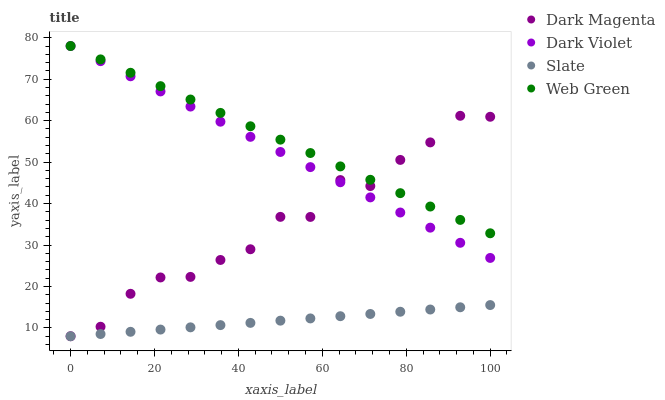Does Slate have the minimum area under the curve?
Answer yes or no. Yes. Does Web Green have the maximum area under the curve?
Answer yes or no. Yes. Does Dark Magenta have the minimum area under the curve?
Answer yes or no. No. Does Dark Magenta have the maximum area under the curve?
Answer yes or no. No. Is Slate the smoothest?
Answer yes or no. Yes. Is Dark Magenta the roughest?
Answer yes or no. Yes. Is Web Green the smoothest?
Answer yes or no. No. Is Web Green the roughest?
Answer yes or no. No. Does Slate have the lowest value?
Answer yes or no. Yes. Does Web Green have the lowest value?
Answer yes or no. No. Does Dark Violet have the highest value?
Answer yes or no. Yes. Does Dark Magenta have the highest value?
Answer yes or no. No. Is Slate less than Web Green?
Answer yes or no. Yes. Is Dark Violet greater than Slate?
Answer yes or no. Yes. Does Dark Violet intersect Web Green?
Answer yes or no. Yes. Is Dark Violet less than Web Green?
Answer yes or no. No. Is Dark Violet greater than Web Green?
Answer yes or no. No. Does Slate intersect Web Green?
Answer yes or no. No. 